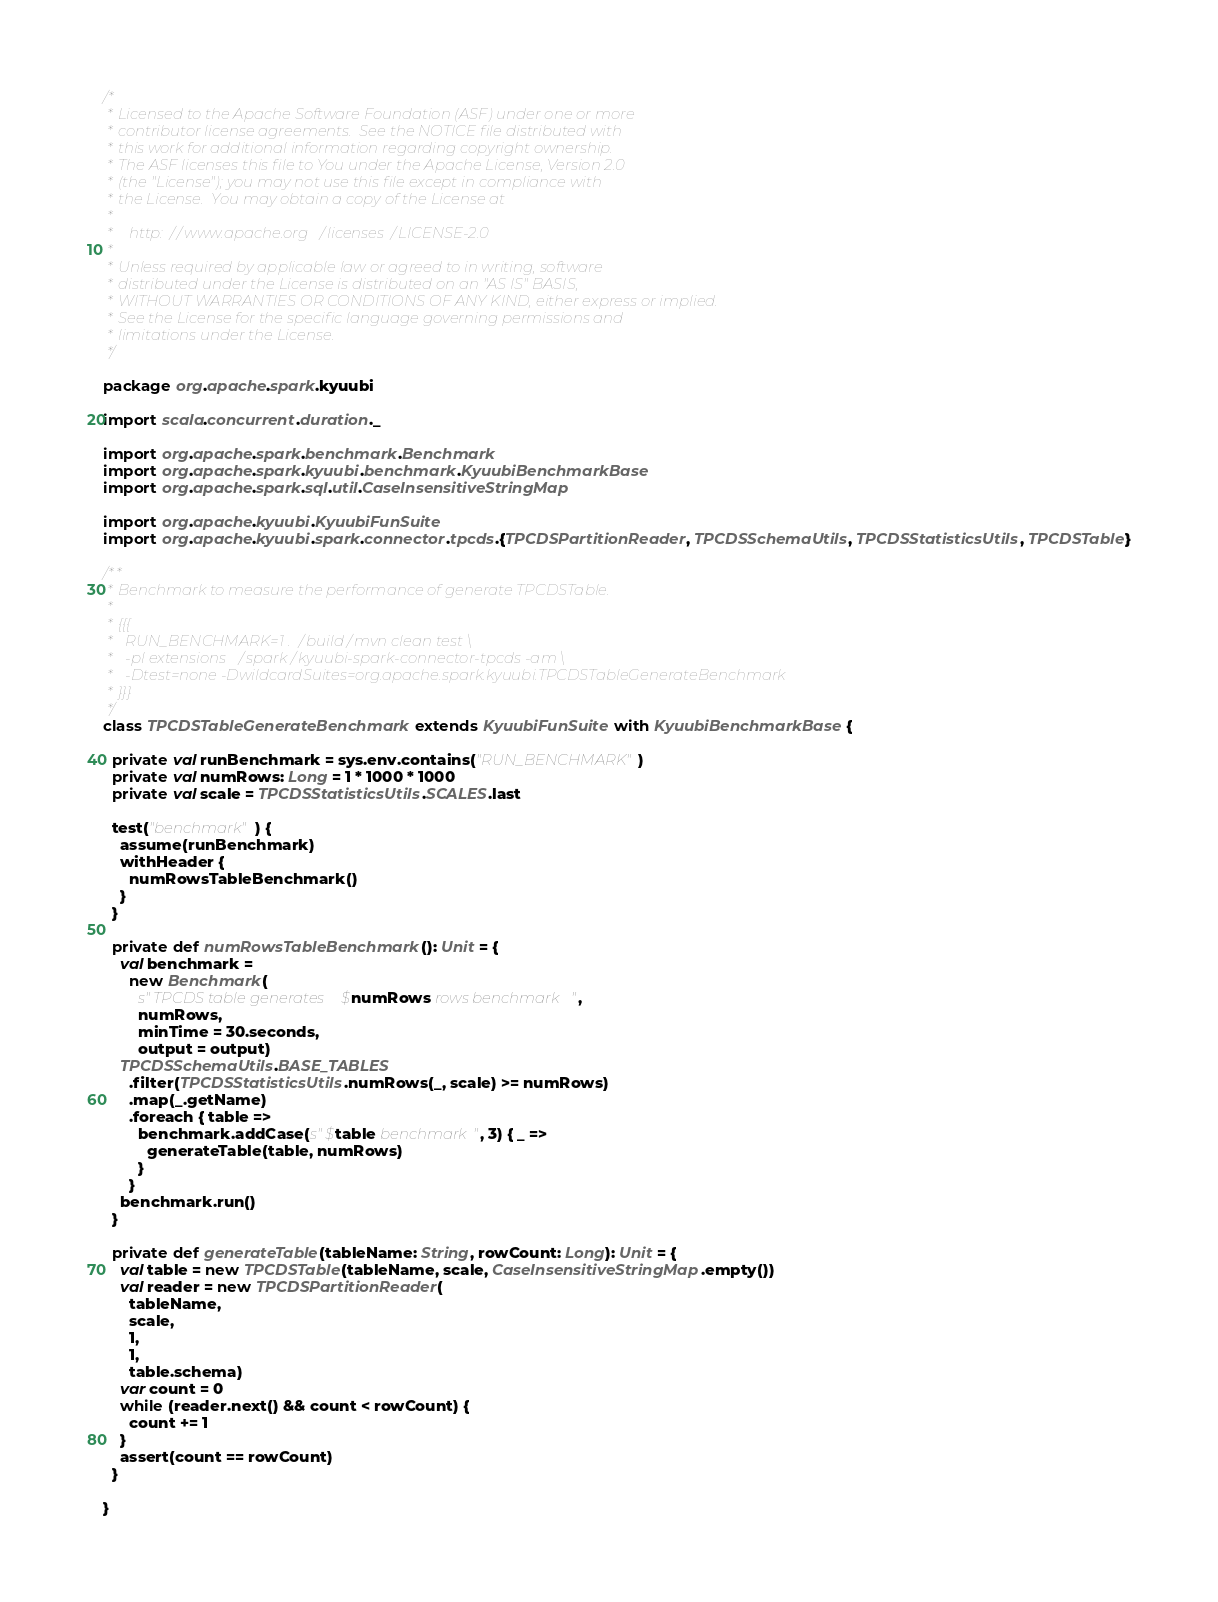Convert code to text. <code><loc_0><loc_0><loc_500><loc_500><_Scala_>/*
 * Licensed to the Apache Software Foundation (ASF) under one or more
 * contributor license agreements.  See the NOTICE file distributed with
 * this work for additional information regarding copyright ownership.
 * The ASF licenses this file to You under the Apache License, Version 2.0
 * (the "License"); you may not use this file except in compliance with
 * the License.  You may obtain a copy of the License at
 *
 *    http://www.apache.org/licenses/LICENSE-2.0
 *
 * Unless required by applicable law or agreed to in writing, software
 * distributed under the License is distributed on an "AS IS" BASIS,
 * WITHOUT WARRANTIES OR CONDITIONS OF ANY KIND, either express or implied.
 * See the License for the specific language governing permissions and
 * limitations under the License.
 */

package org.apache.spark.kyuubi

import scala.concurrent.duration._

import org.apache.spark.benchmark.Benchmark
import org.apache.spark.kyuubi.benchmark.KyuubiBenchmarkBase
import org.apache.spark.sql.util.CaseInsensitiveStringMap

import org.apache.kyuubi.KyuubiFunSuite
import org.apache.kyuubi.spark.connector.tpcds.{TPCDSPartitionReader, TPCDSSchemaUtils, TPCDSStatisticsUtils, TPCDSTable}

/**
 * Benchmark to measure the performance of generate TPCDSTable.
 *
 * {{{
 *   RUN_BENCHMARK=1 ./build/mvn clean test \
 *   -pl extensions/spark/kyuubi-spark-connector-tpcds -am \
 *   -Dtest=none -DwildcardSuites=org.apache.spark.kyuubi.TPCDSTableGenerateBenchmark
 * }}}
 */
class TPCDSTableGenerateBenchmark extends KyuubiFunSuite with KyuubiBenchmarkBase {

  private val runBenchmark = sys.env.contains("RUN_BENCHMARK")
  private val numRows: Long = 1 * 1000 * 1000
  private val scale = TPCDSStatisticsUtils.SCALES.last

  test("benchmark") {
    assume(runBenchmark)
    withHeader {
      numRowsTableBenchmark()
    }
  }

  private def numRowsTableBenchmark(): Unit = {
    val benchmark =
      new Benchmark(
        s"TPCDS table generates $numRows rows benchmark",
        numRows,
        minTime = 30.seconds,
        output = output)
    TPCDSSchemaUtils.BASE_TABLES
      .filter(TPCDSStatisticsUtils.numRows(_, scale) >= numRows)
      .map(_.getName)
      .foreach { table =>
        benchmark.addCase(s"$table benchmark", 3) { _ =>
          generateTable(table, numRows)
        }
      }
    benchmark.run()
  }

  private def generateTable(tableName: String, rowCount: Long): Unit = {
    val table = new TPCDSTable(tableName, scale, CaseInsensitiveStringMap.empty())
    val reader = new TPCDSPartitionReader(
      tableName,
      scale,
      1,
      1,
      table.schema)
    var count = 0
    while (reader.next() && count < rowCount) {
      count += 1
    }
    assert(count == rowCount)
  }

}
</code> 